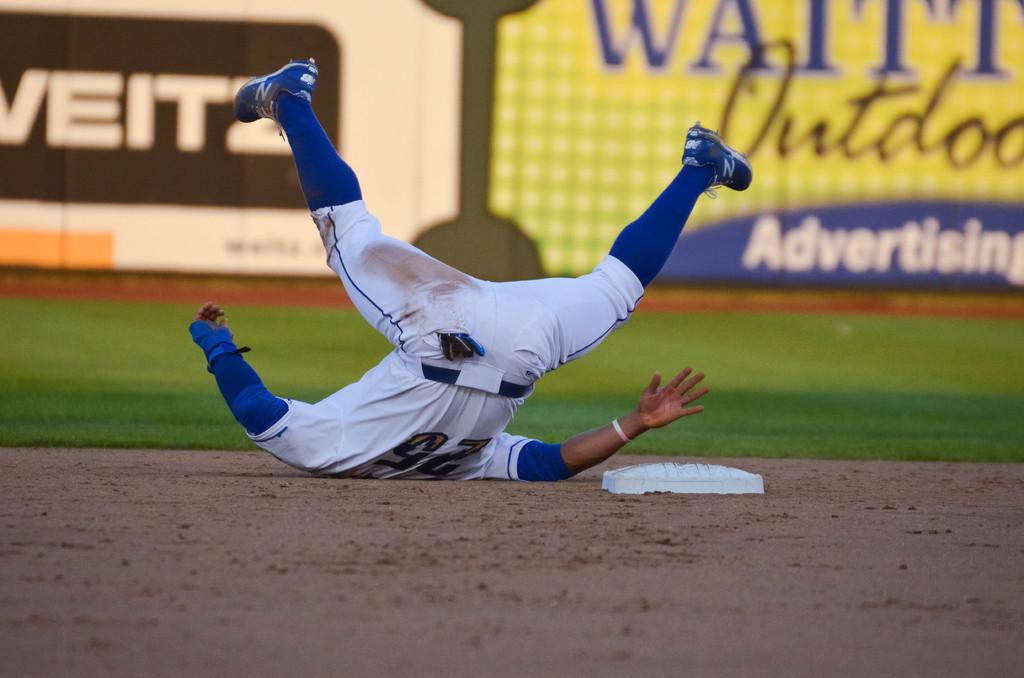<image>
Relay a brief, clear account of the picture shown. The number 25 player falls to the ground 